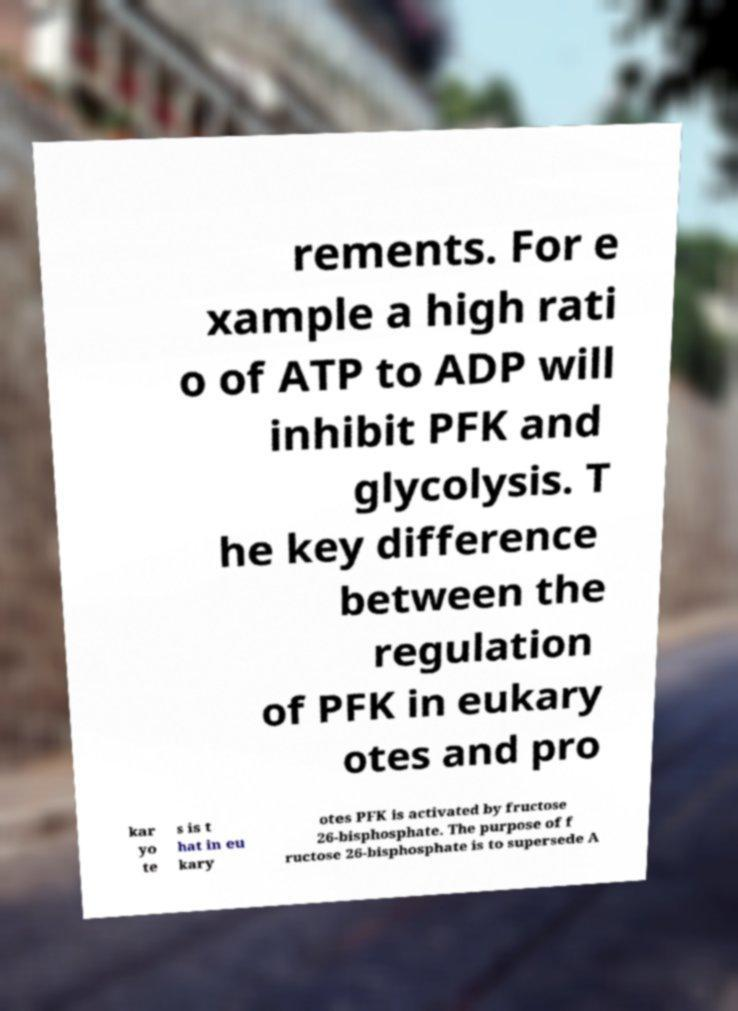Please identify and transcribe the text found in this image. rements. For e xample a high rati o of ATP to ADP will inhibit PFK and glycolysis. T he key difference between the regulation of PFK in eukary otes and pro kar yo te s is t hat in eu kary otes PFK is activated by fructose 26-bisphosphate. The purpose of f ructose 26-bisphosphate is to supersede A 